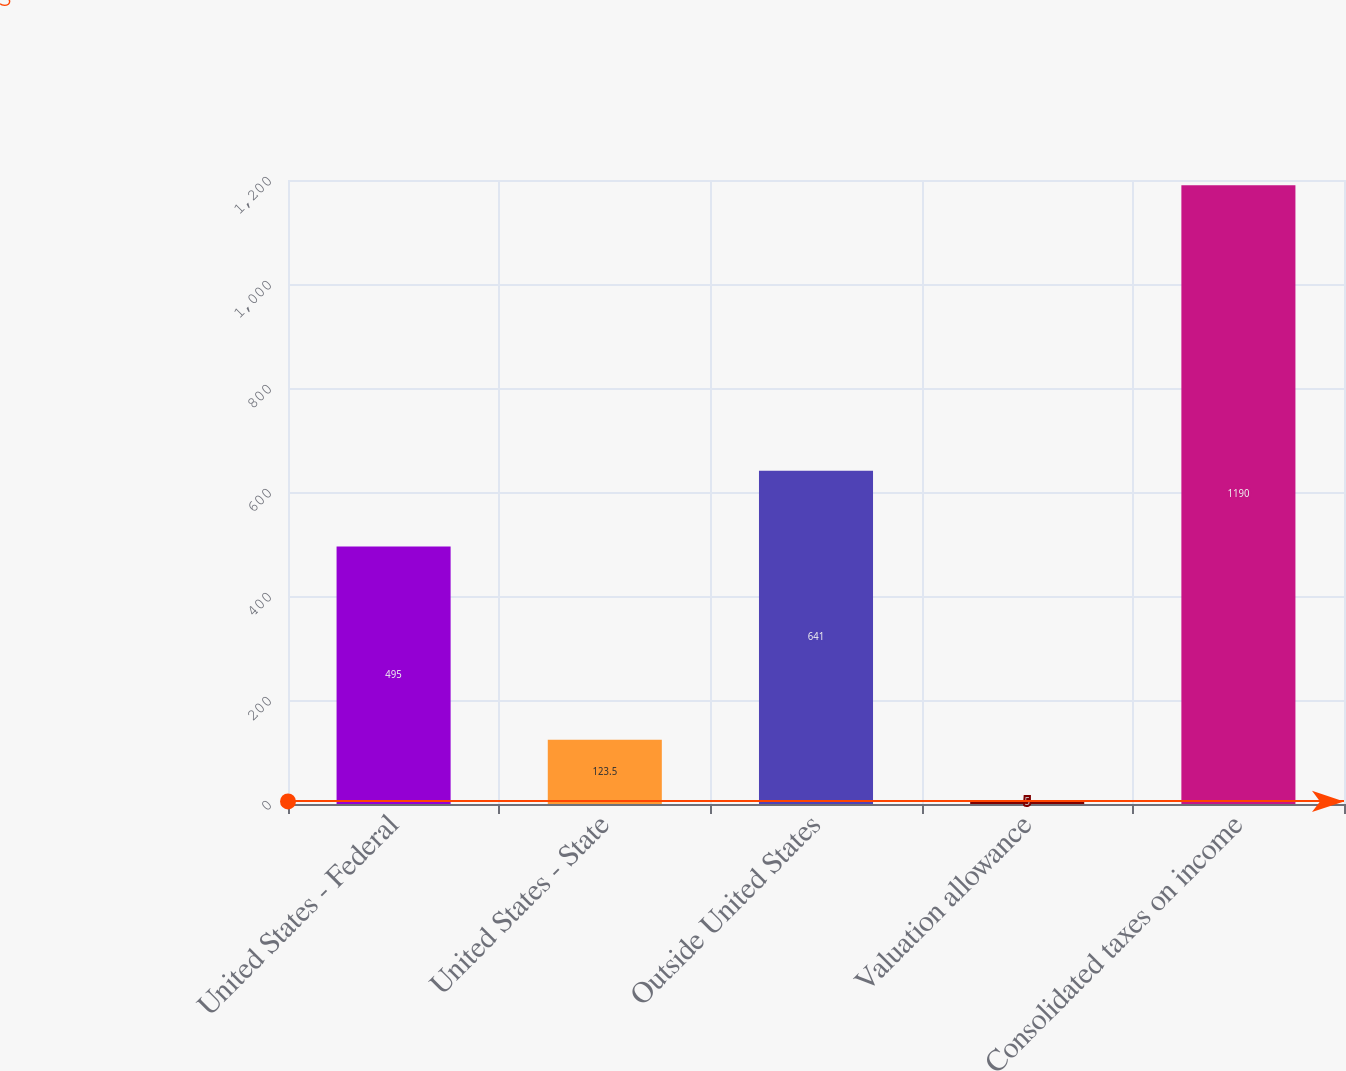<chart> <loc_0><loc_0><loc_500><loc_500><bar_chart><fcel>United States - Federal<fcel>United States - State<fcel>Outside United States<fcel>Valuation allowance<fcel>Consolidated taxes on income<nl><fcel>495<fcel>123.5<fcel>641<fcel>5<fcel>1190<nl></chart> 